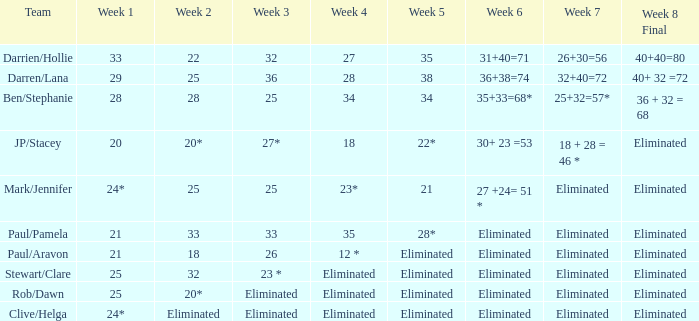Mention the team of mark/jennifer during week 25.0. 